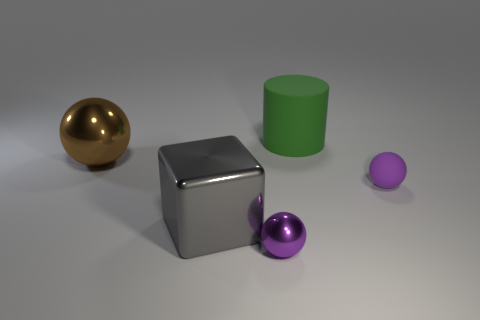Subtract all small metal spheres. How many spheres are left? 2 Subtract all brown balls. How many balls are left? 2 Subtract all cubes. How many objects are left? 4 Subtract 3 balls. How many balls are left? 0 Subtract all green blocks. How many red balls are left? 0 Add 3 metal things. How many metal things exist? 6 Add 5 matte spheres. How many objects exist? 10 Subtract 0 blue blocks. How many objects are left? 5 Subtract all yellow spheres. Subtract all blue cylinders. How many spheres are left? 3 Subtract all yellow cylinders. Subtract all large green rubber things. How many objects are left? 4 